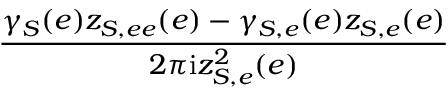<formula> <loc_0><loc_0><loc_500><loc_500>\frac { \gamma _ { S } ( e ) z _ { S , e e } ( e ) - \gamma _ { S , e } ( e ) z _ { S , e } ( e ) } { 2 \pi i z _ { S , e } ^ { 2 } ( e ) }</formula> 